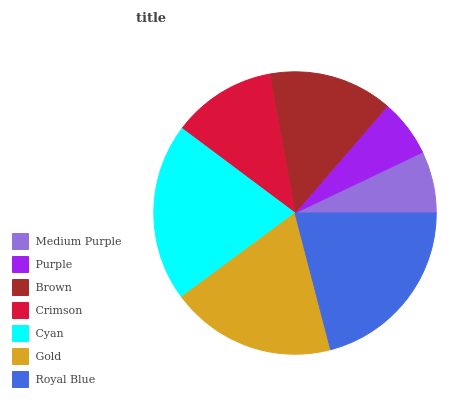Is Purple the minimum?
Answer yes or no. Yes. Is Royal Blue the maximum?
Answer yes or no. Yes. Is Brown the minimum?
Answer yes or no. No. Is Brown the maximum?
Answer yes or no. No. Is Brown greater than Purple?
Answer yes or no. Yes. Is Purple less than Brown?
Answer yes or no. Yes. Is Purple greater than Brown?
Answer yes or no. No. Is Brown less than Purple?
Answer yes or no. No. Is Brown the high median?
Answer yes or no. Yes. Is Brown the low median?
Answer yes or no. Yes. Is Gold the high median?
Answer yes or no. No. Is Crimson the low median?
Answer yes or no. No. 